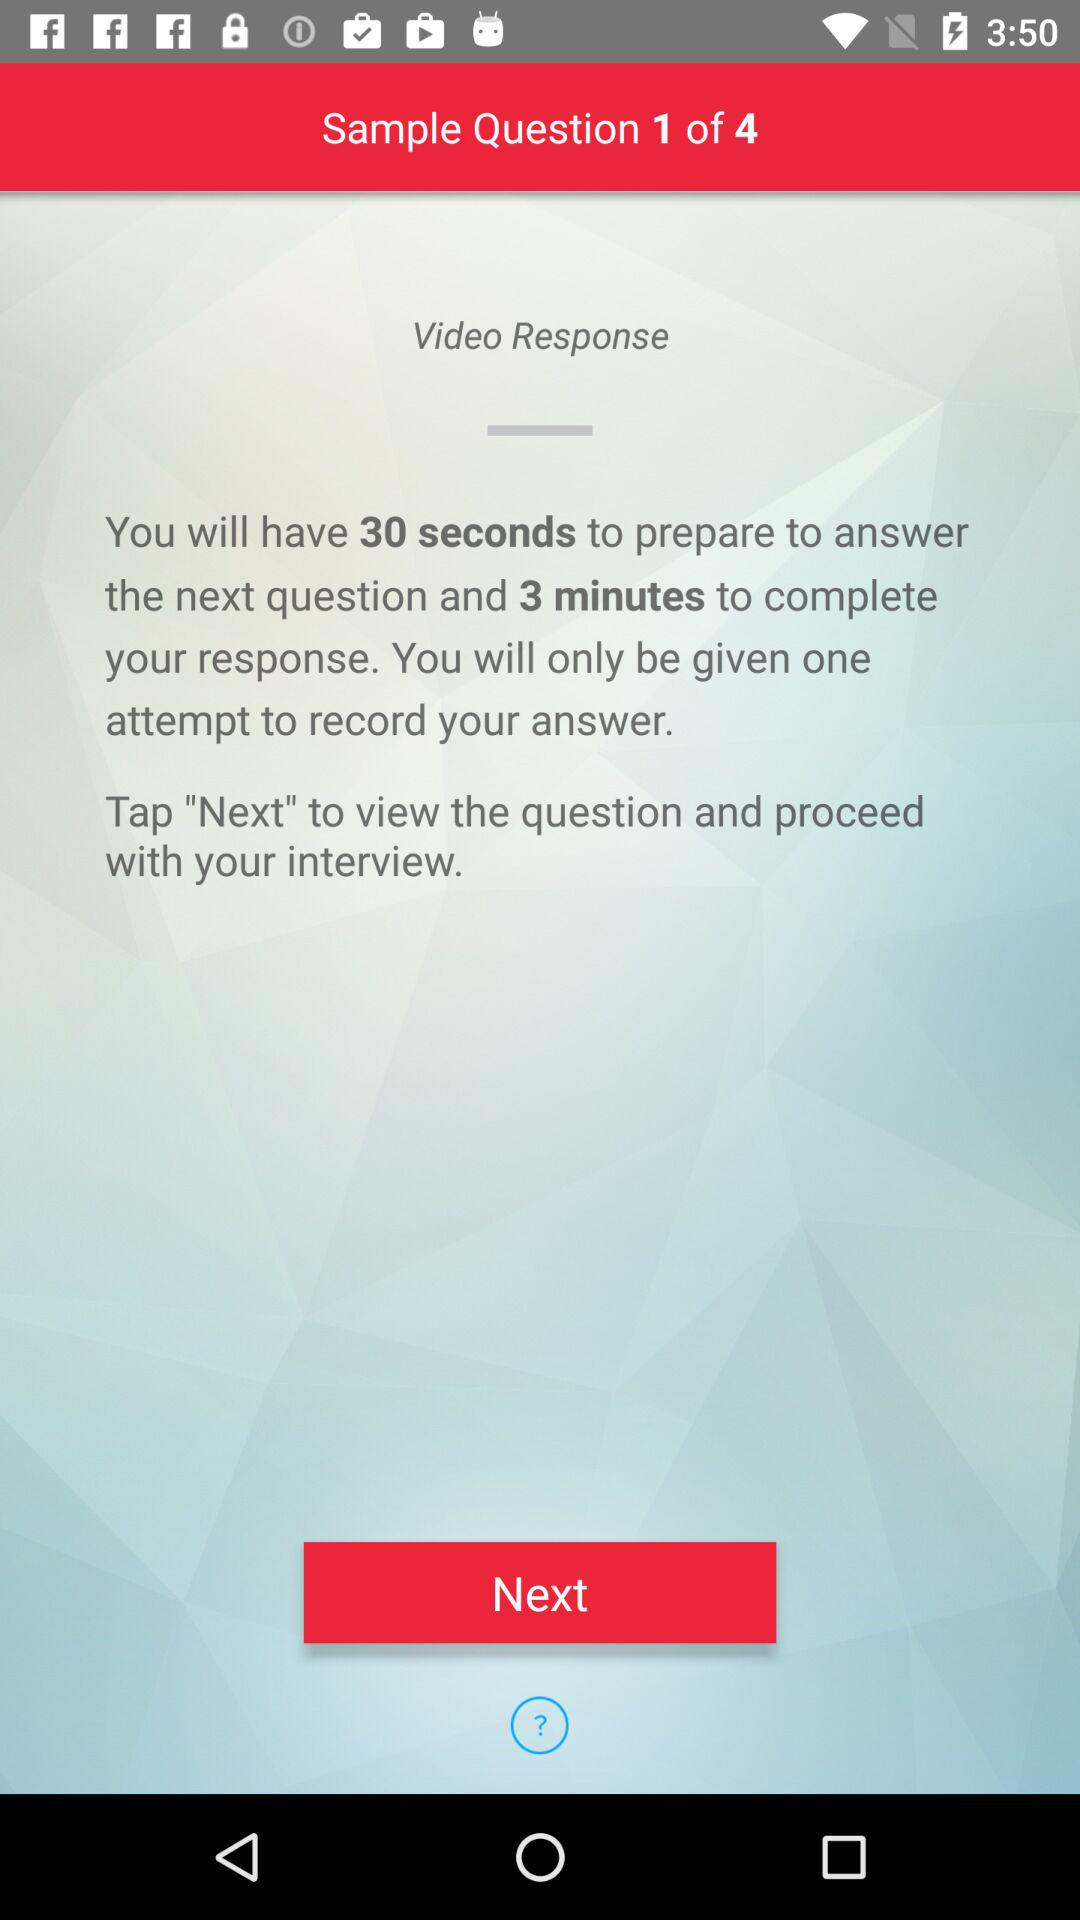How many sample questions in total are there? There are 4 sample questions in total. 